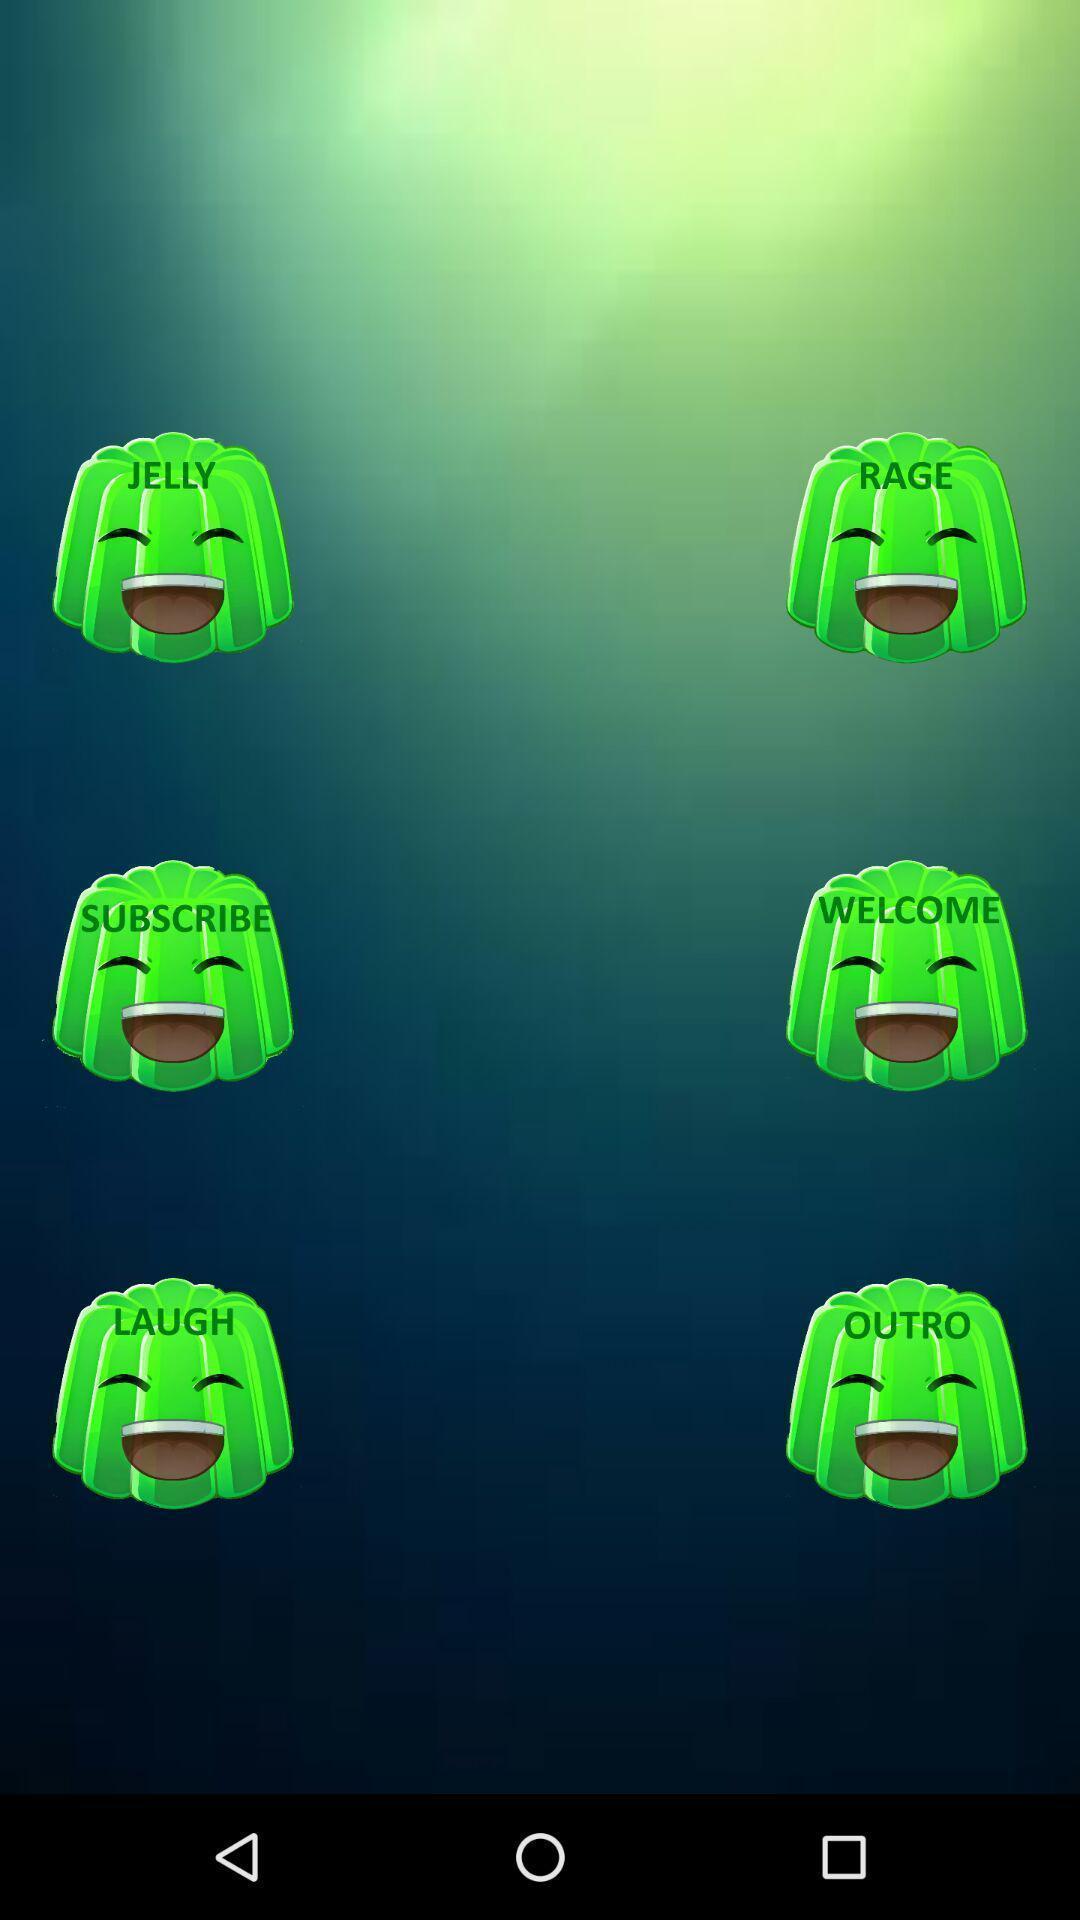Provide a textual representation of this image. Page showing multiple icons. 